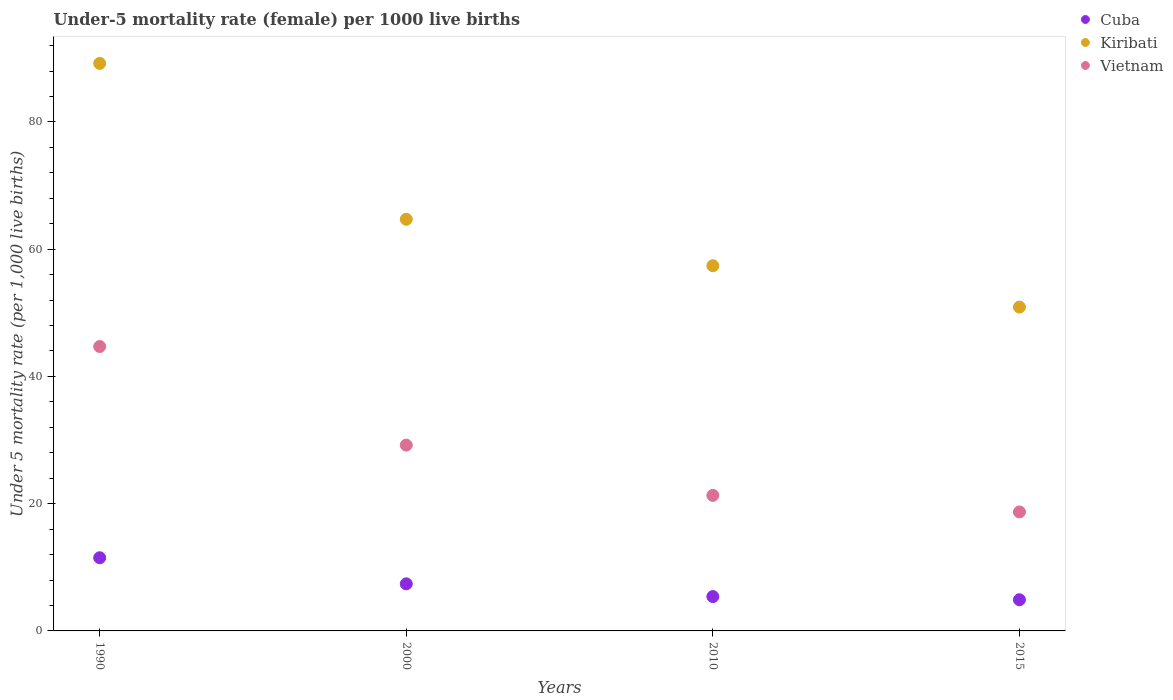What is the under-five mortality rate in Vietnam in 2015?
Provide a short and direct response. 18.7. Across all years, what is the minimum under-five mortality rate in Vietnam?
Offer a very short reply. 18.7. In which year was the under-five mortality rate in Vietnam minimum?
Your response must be concise. 2015. What is the total under-five mortality rate in Vietnam in the graph?
Your answer should be compact. 113.9. What is the difference between the under-five mortality rate in Kiribati in 1990 and that in 2015?
Offer a very short reply. 38.3. What is the difference between the under-five mortality rate in Cuba in 2015 and the under-five mortality rate in Kiribati in 2000?
Provide a succinct answer. -59.8. What is the average under-five mortality rate in Kiribati per year?
Make the answer very short. 65.55. In the year 1990, what is the difference between the under-five mortality rate in Kiribati and under-five mortality rate in Cuba?
Keep it short and to the point. 77.7. In how many years, is the under-five mortality rate in Cuba greater than 52?
Make the answer very short. 0. What is the ratio of the under-five mortality rate in Vietnam in 2010 to that in 2015?
Your answer should be compact. 1.14. Is the under-five mortality rate in Vietnam in 1990 less than that in 2000?
Make the answer very short. No. Is the difference between the under-five mortality rate in Kiribati in 2010 and 2015 greater than the difference between the under-five mortality rate in Cuba in 2010 and 2015?
Your response must be concise. Yes. What is the difference between the highest and the lowest under-five mortality rate in Kiribati?
Make the answer very short. 38.3. In how many years, is the under-five mortality rate in Kiribati greater than the average under-five mortality rate in Kiribati taken over all years?
Provide a short and direct response. 1. Is the sum of the under-five mortality rate in Vietnam in 2010 and 2015 greater than the maximum under-five mortality rate in Kiribati across all years?
Provide a succinct answer. No. What is the difference between two consecutive major ticks on the Y-axis?
Keep it short and to the point. 20. Does the graph contain any zero values?
Make the answer very short. No. Where does the legend appear in the graph?
Provide a succinct answer. Top right. How many legend labels are there?
Offer a very short reply. 3. How are the legend labels stacked?
Give a very brief answer. Vertical. What is the title of the graph?
Ensure brevity in your answer.  Under-5 mortality rate (female) per 1000 live births. What is the label or title of the Y-axis?
Your answer should be very brief. Under 5 mortality rate (per 1,0 live births). What is the Under 5 mortality rate (per 1,000 live births) in Kiribati in 1990?
Provide a succinct answer. 89.2. What is the Under 5 mortality rate (per 1,000 live births) in Vietnam in 1990?
Provide a short and direct response. 44.7. What is the Under 5 mortality rate (per 1,000 live births) in Kiribati in 2000?
Ensure brevity in your answer.  64.7. What is the Under 5 mortality rate (per 1,000 live births) in Vietnam in 2000?
Offer a very short reply. 29.2. What is the Under 5 mortality rate (per 1,000 live births) in Kiribati in 2010?
Your answer should be compact. 57.4. What is the Under 5 mortality rate (per 1,000 live births) in Vietnam in 2010?
Offer a terse response. 21.3. What is the Under 5 mortality rate (per 1,000 live births) of Cuba in 2015?
Offer a terse response. 4.9. What is the Under 5 mortality rate (per 1,000 live births) in Kiribati in 2015?
Give a very brief answer. 50.9. What is the Under 5 mortality rate (per 1,000 live births) in Vietnam in 2015?
Give a very brief answer. 18.7. Across all years, what is the maximum Under 5 mortality rate (per 1,000 live births) in Kiribati?
Your response must be concise. 89.2. Across all years, what is the maximum Under 5 mortality rate (per 1,000 live births) of Vietnam?
Make the answer very short. 44.7. Across all years, what is the minimum Under 5 mortality rate (per 1,000 live births) of Cuba?
Make the answer very short. 4.9. Across all years, what is the minimum Under 5 mortality rate (per 1,000 live births) of Kiribati?
Give a very brief answer. 50.9. Across all years, what is the minimum Under 5 mortality rate (per 1,000 live births) in Vietnam?
Offer a terse response. 18.7. What is the total Under 5 mortality rate (per 1,000 live births) of Cuba in the graph?
Your answer should be compact. 29.2. What is the total Under 5 mortality rate (per 1,000 live births) in Kiribati in the graph?
Your answer should be compact. 262.2. What is the total Under 5 mortality rate (per 1,000 live births) of Vietnam in the graph?
Provide a short and direct response. 113.9. What is the difference between the Under 5 mortality rate (per 1,000 live births) in Cuba in 1990 and that in 2000?
Give a very brief answer. 4.1. What is the difference between the Under 5 mortality rate (per 1,000 live births) of Vietnam in 1990 and that in 2000?
Your answer should be very brief. 15.5. What is the difference between the Under 5 mortality rate (per 1,000 live births) in Kiribati in 1990 and that in 2010?
Give a very brief answer. 31.8. What is the difference between the Under 5 mortality rate (per 1,000 live births) in Vietnam in 1990 and that in 2010?
Offer a terse response. 23.4. What is the difference between the Under 5 mortality rate (per 1,000 live births) of Cuba in 1990 and that in 2015?
Your response must be concise. 6.6. What is the difference between the Under 5 mortality rate (per 1,000 live births) of Kiribati in 1990 and that in 2015?
Your response must be concise. 38.3. What is the difference between the Under 5 mortality rate (per 1,000 live births) in Cuba in 2000 and that in 2015?
Your response must be concise. 2.5. What is the difference between the Under 5 mortality rate (per 1,000 live births) in Kiribati in 2000 and that in 2015?
Your answer should be very brief. 13.8. What is the difference between the Under 5 mortality rate (per 1,000 live births) of Cuba in 2010 and that in 2015?
Keep it short and to the point. 0.5. What is the difference between the Under 5 mortality rate (per 1,000 live births) of Kiribati in 2010 and that in 2015?
Offer a terse response. 6.5. What is the difference between the Under 5 mortality rate (per 1,000 live births) of Vietnam in 2010 and that in 2015?
Make the answer very short. 2.6. What is the difference between the Under 5 mortality rate (per 1,000 live births) in Cuba in 1990 and the Under 5 mortality rate (per 1,000 live births) in Kiribati in 2000?
Give a very brief answer. -53.2. What is the difference between the Under 5 mortality rate (per 1,000 live births) in Cuba in 1990 and the Under 5 mortality rate (per 1,000 live births) in Vietnam in 2000?
Provide a short and direct response. -17.7. What is the difference between the Under 5 mortality rate (per 1,000 live births) of Cuba in 1990 and the Under 5 mortality rate (per 1,000 live births) of Kiribati in 2010?
Make the answer very short. -45.9. What is the difference between the Under 5 mortality rate (per 1,000 live births) in Cuba in 1990 and the Under 5 mortality rate (per 1,000 live births) in Vietnam in 2010?
Keep it short and to the point. -9.8. What is the difference between the Under 5 mortality rate (per 1,000 live births) in Kiribati in 1990 and the Under 5 mortality rate (per 1,000 live births) in Vietnam in 2010?
Your answer should be compact. 67.9. What is the difference between the Under 5 mortality rate (per 1,000 live births) in Cuba in 1990 and the Under 5 mortality rate (per 1,000 live births) in Kiribati in 2015?
Your answer should be very brief. -39.4. What is the difference between the Under 5 mortality rate (per 1,000 live births) in Cuba in 1990 and the Under 5 mortality rate (per 1,000 live births) in Vietnam in 2015?
Offer a terse response. -7.2. What is the difference between the Under 5 mortality rate (per 1,000 live births) of Kiribati in 1990 and the Under 5 mortality rate (per 1,000 live births) of Vietnam in 2015?
Your answer should be very brief. 70.5. What is the difference between the Under 5 mortality rate (per 1,000 live births) in Cuba in 2000 and the Under 5 mortality rate (per 1,000 live births) in Kiribati in 2010?
Keep it short and to the point. -50. What is the difference between the Under 5 mortality rate (per 1,000 live births) in Cuba in 2000 and the Under 5 mortality rate (per 1,000 live births) in Vietnam in 2010?
Provide a succinct answer. -13.9. What is the difference between the Under 5 mortality rate (per 1,000 live births) in Kiribati in 2000 and the Under 5 mortality rate (per 1,000 live births) in Vietnam in 2010?
Keep it short and to the point. 43.4. What is the difference between the Under 5 mortality rate (per 1,000 live births) in Cuba in 2000 and the Under 5 mortality rate (per 1,000 live births) in Kiribati in 2015?
Your answer should be very brief. -43.5. What is the difference between the Under 5 mortality rate (per 1,000 live births) of Kiribati in 2000 and the Under 5 mortality rate (per 1,000 live births) of Vietnam in 2015?
Make the answer very short. 46. What is the difference between the Under 5 mortality rate (per 1,000 live births) of Cuba in 2010 and the Under 5 mortality rate (per 1,000 live births) of Kiribati in 2015?
Offer a terse response. -45.5. What is the difference between the Under 5 mortality rate (per 1,000 live births) of Kiribati in 2010 and the Under 5 mortality rate (per 1,000 live births) of Vietnam in 2015?
Your answer should be compact. 38.7. What is the average Under 5 mortality rate (per 1,000 live births) in Cuba per year?
Provide a succinct answer. 7.3. What is the average Under 5 mortality rate (per 1,000 live births) in Kiribati per year?
Provide a short and direct response. 65.55. What is the average Under 5 mortality rate (per 1,000 live births) of Vietnam per year?
Give a very brief answer. 28.48. In the year 1990, what is the difference between the Under 5 mortality rate (per 1,000 live births) of Cuba and Under 5 mortality rate (per 1,000 live births) of Kiribati?
Give a very brief answer. -77.7. In the year 1990, what is the difference between the Under 5 mortality rate (per 1,000 live births) of Cuba and Under 5 mortality rate (per 1,000 live births) of Vietnam?
Offer a very short reply. -33.2. In the year 1990, what is the difference between the Under 5 mortality rate (per 1,000 live births) of Kiribati and Under 5 mortality rate (per 1,000 live births) of Vietnam?
Your answer should be compact. 44.5. In the year 2000, what is the difference between the Under 5 mortality rate (per 1,000 live births) of Cuba and Under 5 mortality rate (per 1,000 live births) of Kiribati?
Ensure brevity in your answer.  -57.3. In the year 2000, what is the difference between the Under 5 mortality rate (per 1,000 live births) of Cuba and Under 5 mortality rate (per 1,000 live births) of Vietnam?
Provide a succinct answer. -21.8. In the year 2000, what is the difference between the Under 5 mortality rate (per 1,000 live births) in Kiribati and Under 5 mortality rate (per 1,000 live births) in Vietnam?
Your answer should be compact. 35.5. In the year 2010, what is the difference between the Under 5 mortality rate (per 1,000 live births) in Cuba and Under 5 mortality rate (per 1,000 live births) in Kiribati?
Ensure brevity in your answer.  -52. In the year 2010, what is the difference between the Under 5 mortality rate (per 1,000 live births) of Cuba and Under 5 mortality rate (per 1,000 live births) of Vietnam?
Your answer should be compact. -15.9. In the year 2010, what is the difference between the Under 5 mortality rate (per 1,000 live births) of Kiribati and Under 5 mortality rate (per 1,000 live births) of Vietnam?
Your answer should be very brief. 36.1. In the year 2015, what is the difference between the Under 5 mortality rate (per 1,000 live births) of Cuba and Under 5 mortality rate (per 1,000 live births) of Kiribati?
Your answer should be compact. -46. In the year 2015, what is the difference between the Under 5 mortality rate (per 1,000 live births) of Cuba and Under 5 mortality rate (per 1,000 live births) of Vietnam?
Offer a terse response. -13.8. In the year 2015, what is the difference between the Under 5 mortality rate (per 1,000 live births) in Kiribati and Under 5 mortality rate (per 1,000 live births) in Vietnam?
Make the answer very short. 32.2. What is the ratio of the Under 5 mortality rate (per 1,000 live births) in Cuba in 1990 to that in 2000?
Offer a terse response. 1.55. What is the ratio of the Under 5 mortality rate (per 1,000 live births) of Kiribati in 1990 to that in 2000?
Your response must be concise. 1.38. What is the ratio of the Under 5 mortality rate (per 1,000 live births) of Vietnam in 1990 to that in 2000?
Provide a succinct answer. 1.53. What is the ratio of the Under 5 mortality rate (per 1,000 live births) of Cuba in 1990 to that in 2010?
Offer a very short reply. 2.13. What is the ratio of the Under 5 mortality rate (per 1,000 live births) of Kiribati in 1990 to that in 2010?
Keep it short and to the point. 1.55. What is the ratio of the Under 5 mortality rate (per 1,000 live births) in Vietnam in 1990 to that in 2010?
Your answer should be very brief. 2.1. What is the ratio of the Under 5 mortality rate (per 1,000 live births) of Cuba in 1990 to that in 2015?
Provide a succinct answer. 2.35. What is the ratio of the Under 5 mortality rate (per 1,000 live births) of Kiribati in 1990 to that in 2015?
Your answer should be very brief. 1.75. What is the ratio of the Under 5 mortality rate (per 1,000 live births) of Vietnam in 1990 to that in 2015?
Make the answer very short. 2.39. What is the ratio of the Under 5 mortality rate (per 1,000 live births) in Cuba in 2000 to that in 2010?
Keep it short and to the point. 1.37. What is the ratio of the Under 5 mortality rate (per 1,000 live births) of Kiribati in 2000 to that in 2010?
Provide a succinct answer. 1.13. What is the ratio of the Under 5 mortality rate (per 1,000 live births) in Vietnam in 2000 to that in 2010?
Make the answer very short. 1.37. What is the ratio of the Under 5 mortality rate (per 1,000 live births) in Cuba in 2000 to that in 2015?
Give a very brief answer. 1.51. What is the ratio of the Under 5 mortality rate (per 1,000 live births) of Kiribati in 2000 to that in 2015?
Provide a succinct answer. 1.27. What is the ratio of the Under 5 mortality rate (per 1,000 live births) of Vietnam in 2000 to that in 2015?
Your response must be concise. 1.56. What is the ratio of the Under 5 mortality rate (per 1,000 live births) in Cuba in 2010 to that in 2015?
Offer a terse response. 1.1. What is the ratio of the Under 5 mortality rate (per 1,000 live births) of Kiribati in 2010 to that in 2015?
Ensure brevity in your answer.  1.13. What is the ratio of the Under 5 mortality rate (per 1,000 live births) of Vietnam in 2010 to that in 2015?
Ensure brevity in your answer.  1.14. What is the difference between the highest and the second highest Under 5 mortality rate (per 1,000 live births) in Cuba?
Your answer should be compact. 4.1. What is the difference between the highest and the second highest Under 5 mortality rate (per 1,000 live births) in Vietnam?
Your answer should be very brief. 15.5. What is the difference between the highest and the lowest Under 5 mortality rate (per 1,000 live births) in Cuba?
Make the answer very short. 6.6. What is the difference between the highest and the lowest Under 5 mortality rate (per 1,000 live births) of Kiribati?
Offer a very short reply. 38.3. What is the difference between the highest and the lowest Under 5 mortality rate (per 1,000 live births) of Vietnam?
Ensure brevity in your answer.  26. 